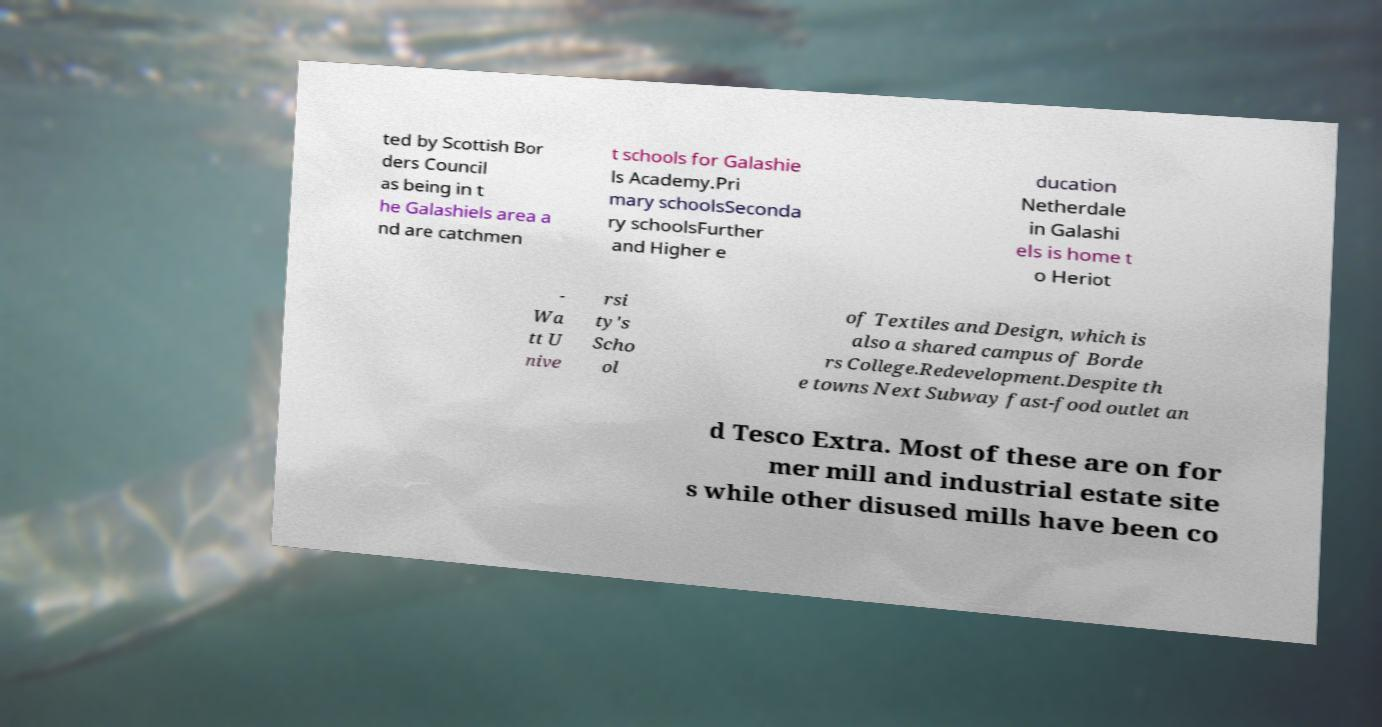Can you accurately transcribe the text from the provided image for me? ted by Scottish Bor ders Council as being in t he Galashiels area a nd are catchmen t schools for Galashie ls Academy.Pri mary schoolsSeconda ry schoolsFurther and Higher e ducation Netherdale in Galashi els is home t o Heriot - Wa tt U nive rsi ty's Scho ol of Textiles and Design, which is also a shared campus of Borde rs College.Redevelopment.Despite th e towns Next Subway fast-food outlet an d Tesco Extra. Most of these are on for mer mill and industrial estate site s while other disused mills have been co 